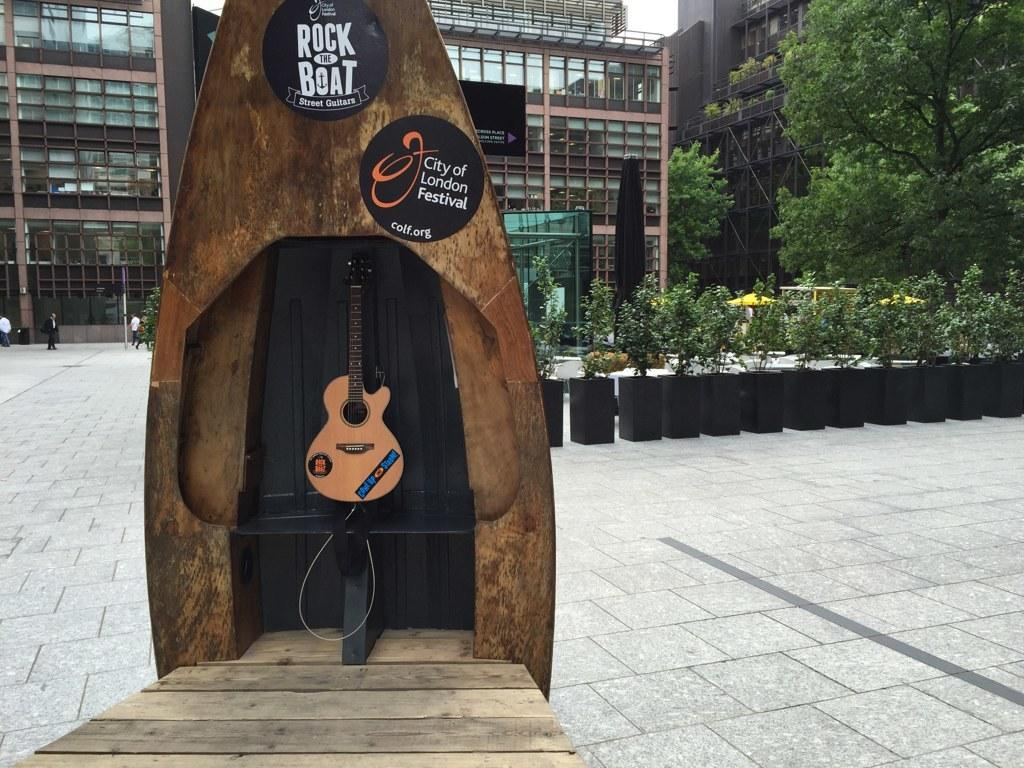What type of structures can be seen in the image? There are buildings in the image. What natural elements are present in the image? There are trees and plants in the image. What object can be seen that is typically used for making music? There is a guitar in the image. Can you see any ants carrying plastic items in the image? There are no ants or plastic items present in the image. What type of brass instrument can be seen in the image? There is no brass instrument present in the image; only a guitar is visible. 